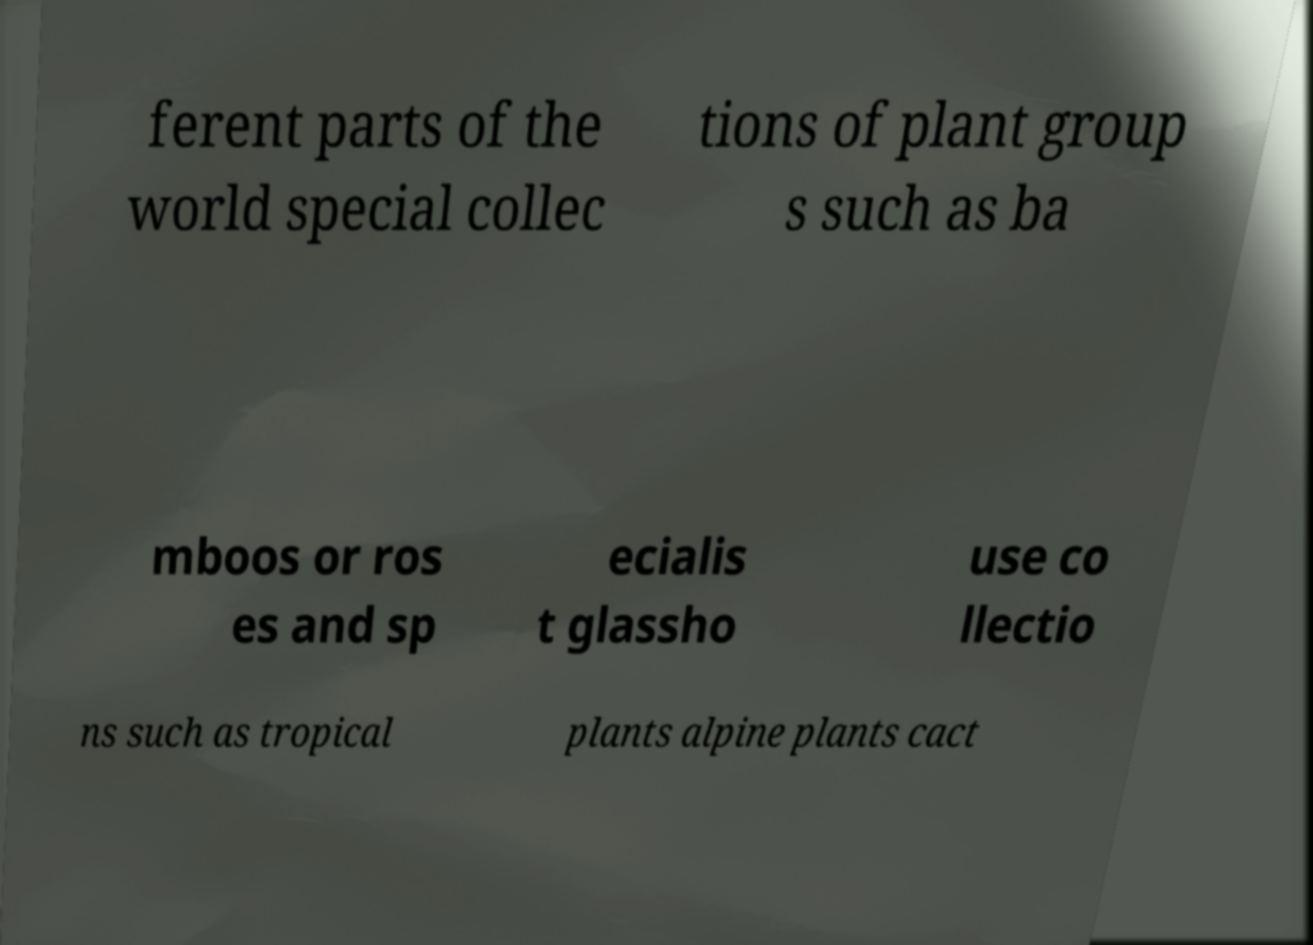There's text embedded in this image that I need extracted. Can you transcribe it verbatim? ferent parts of the world special collec tions of plant group s such as ba mboos or ros es and sp ecialis t glassho use co llectio ns such as tropical plants alpine plants cact 